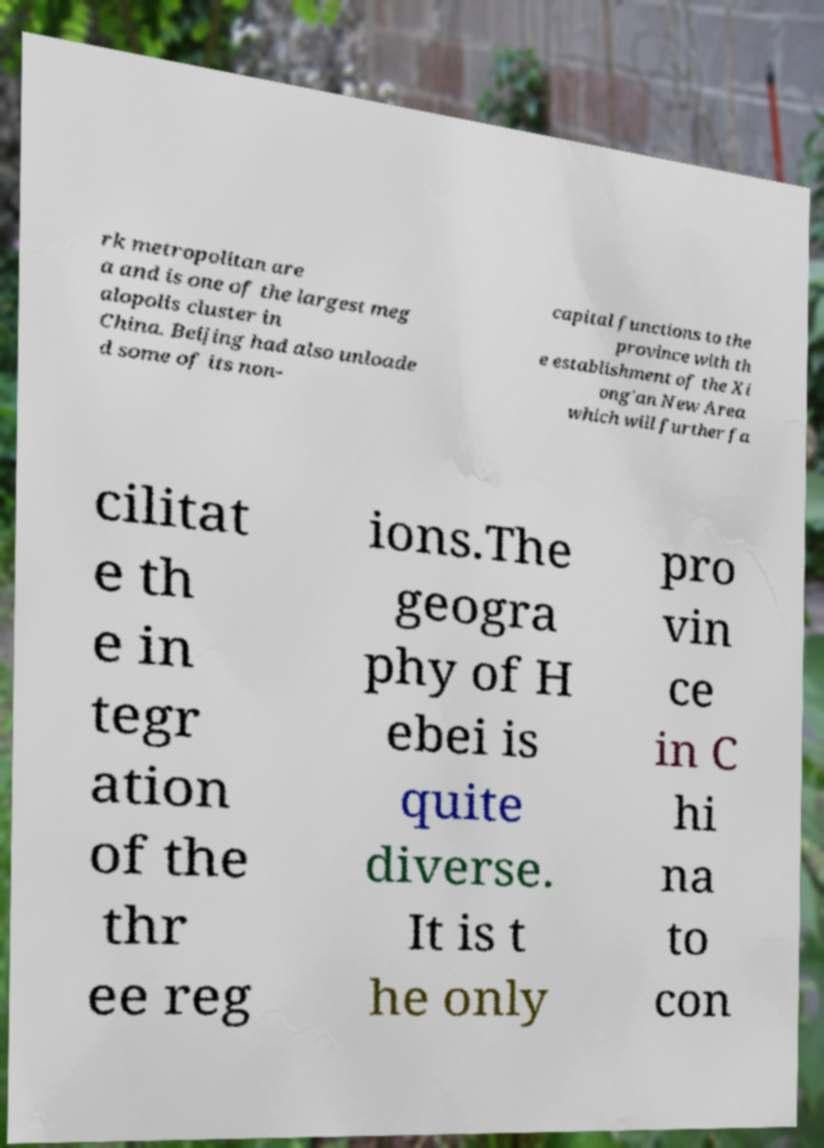Please identify and transcribe the text found in this image. rk metropolitan are a and is one of the largest meg alopolis cluster in China. Beijing had also unloade d some of its non- capital functions to the province with th e establishment of the Xi ong'an New Area which will further fa cilitat e th e in tegr ation of the thr ee reg ions.The geogra phy of H ebei is quite diverse. It is t he only pro vin ce in C hi na to con 